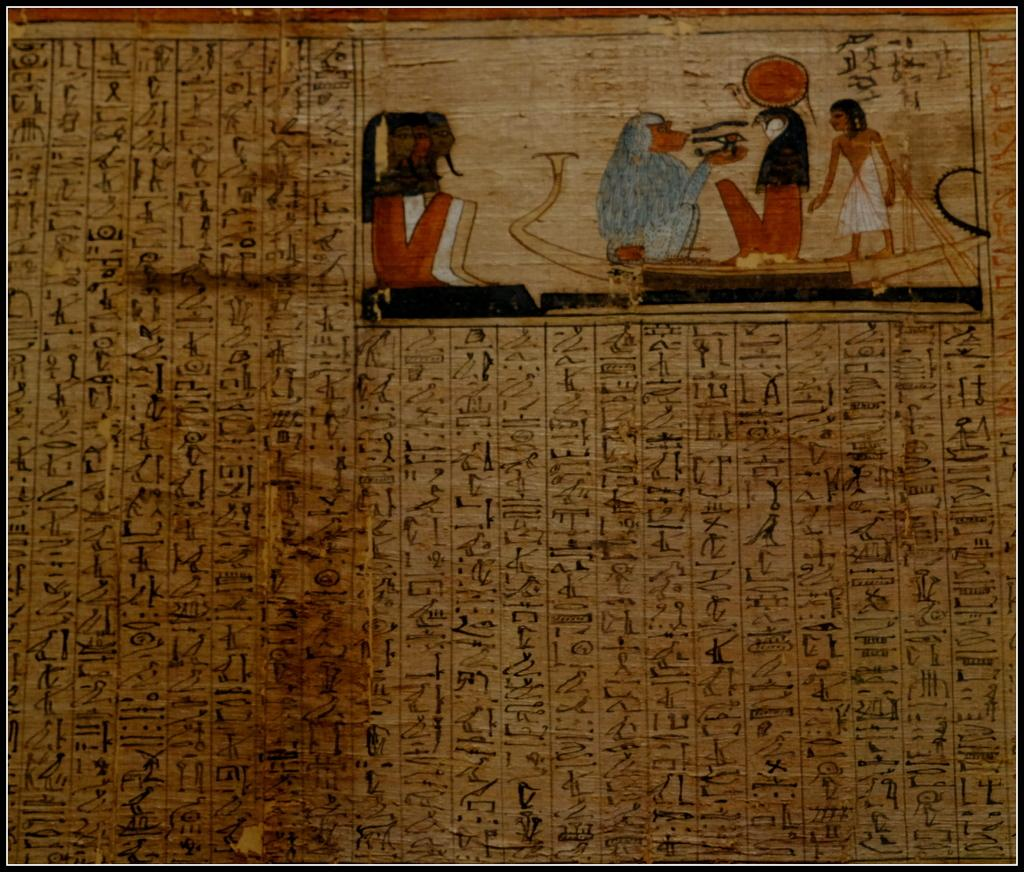What type of artwork is depicted in the image? The image is a painting. What subjects are featured in the painting? There is a painting of a person and a painting of a monkey in the image. Is there any text present in the image? Yes, there is text in the image. Reasoning: Let'g: Let's think step by step in order to produce the conversation. We start by identifying the medium of the artwork, which is a painting. Then, we describe the subjects of the painting, which include a person and a monkey. Finally, we acknowledge the presence of text in the image. Absurd Question/Answer: What type of jeans is the horse wearing in the image? There is no horse or jeans present in the image; it features a painting of a person and a monkey with text. What causes the burst of colors in the image? The image does not depict a burst of colors; it is a painting with a person, a monkey, and text. How does the ice cream move around in the image? The ice cream does not move around in the image; it is stationary in the bowl. 